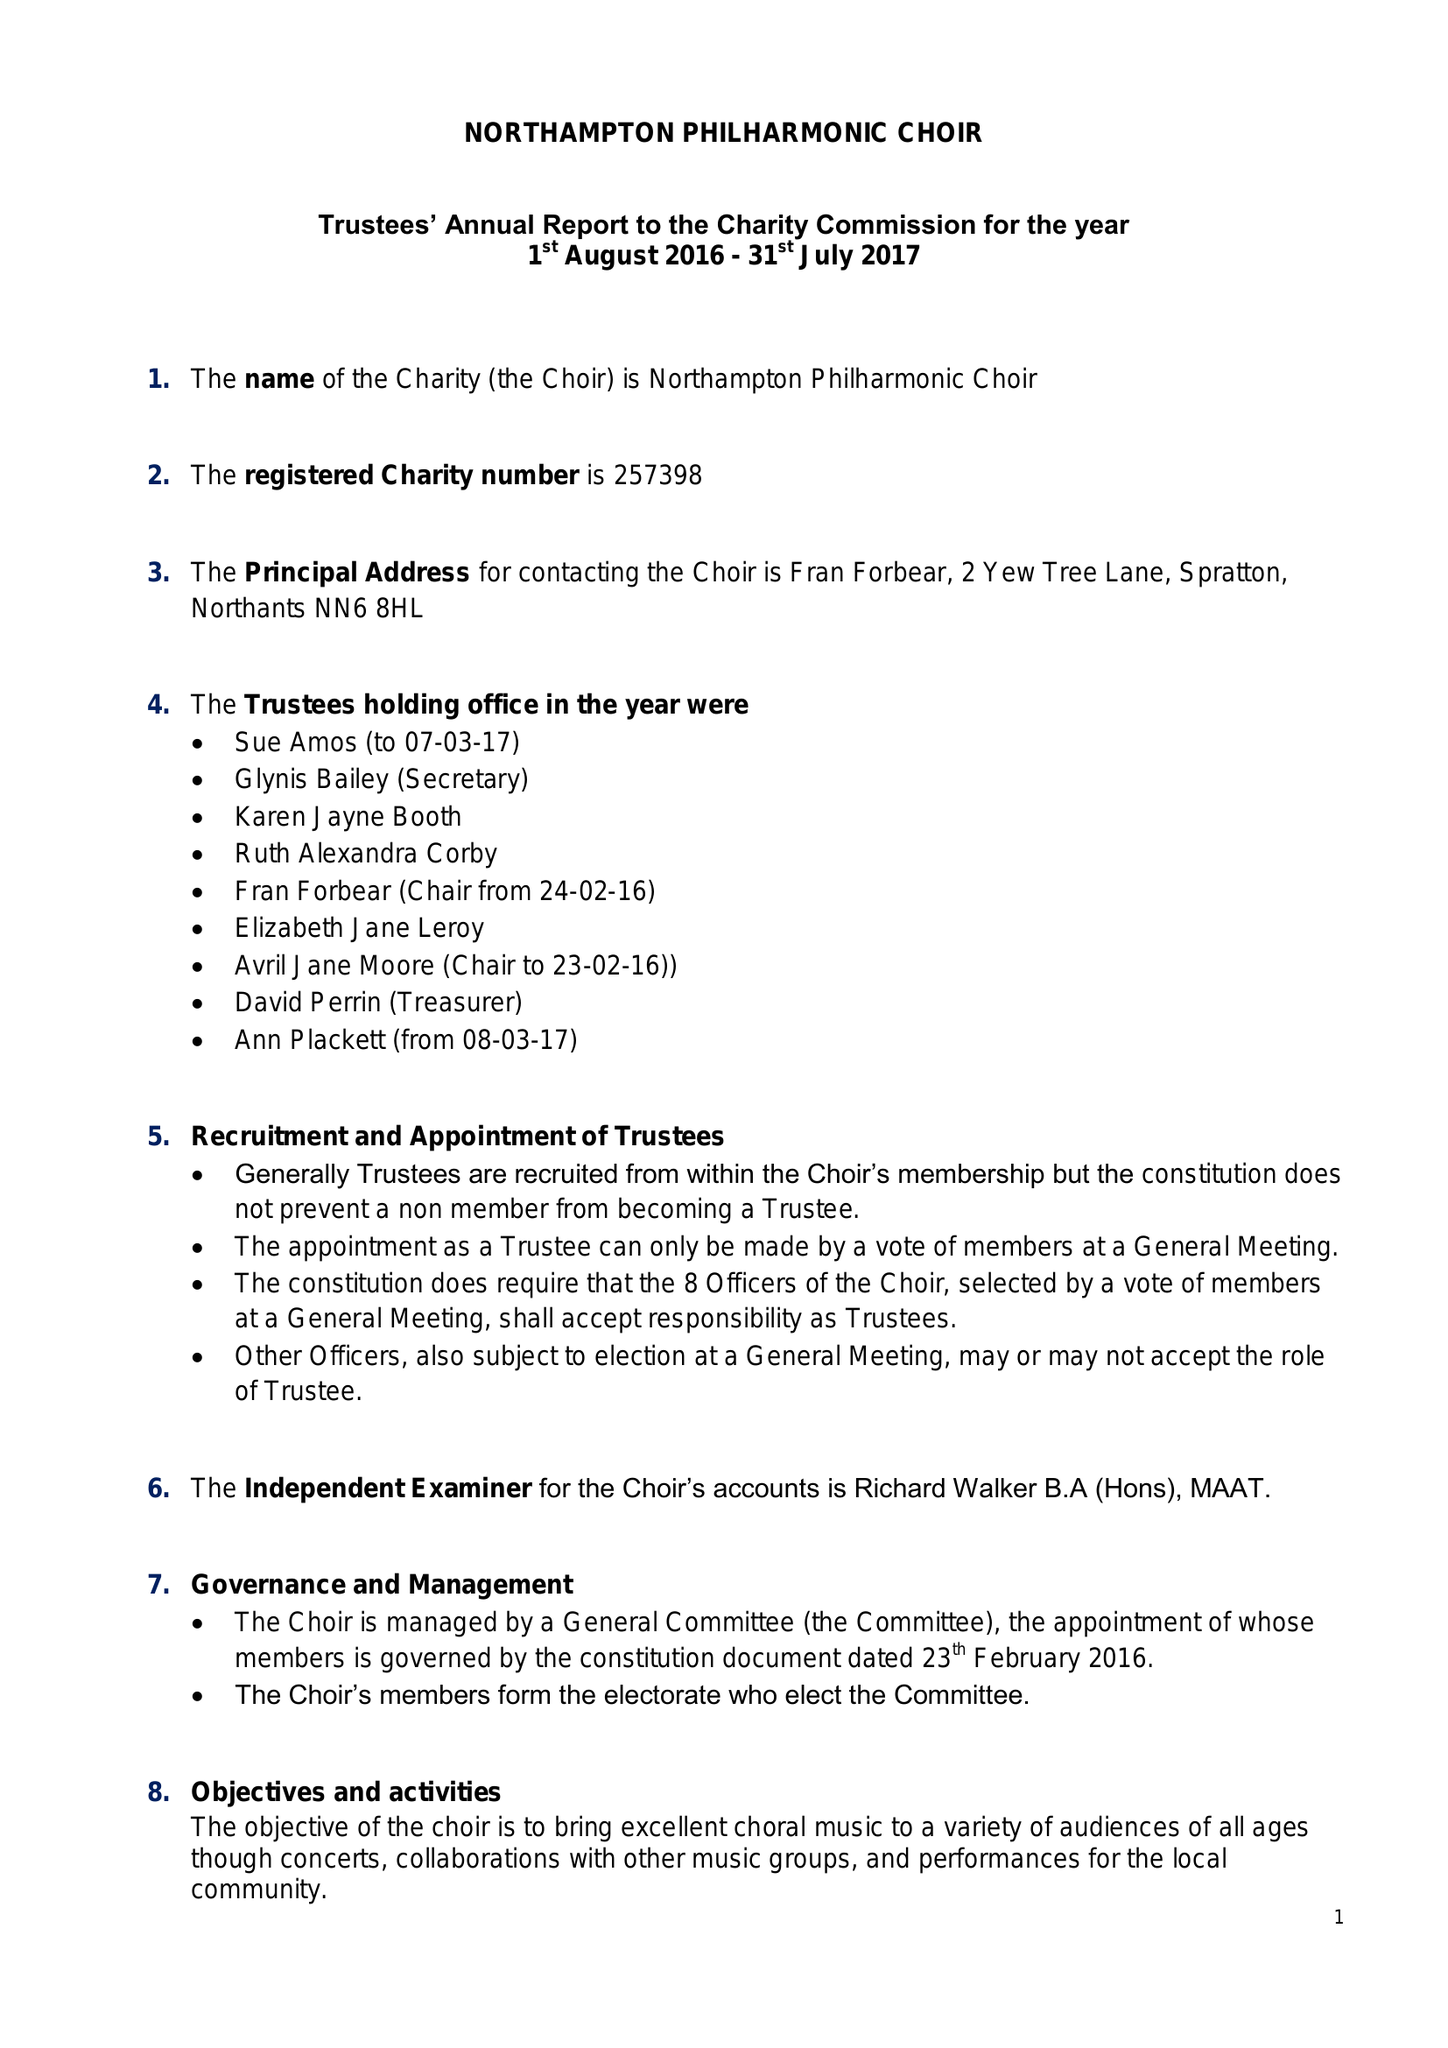What is the value for the report_date?
Answer the question using a single word or phrase. 2017-07-31 